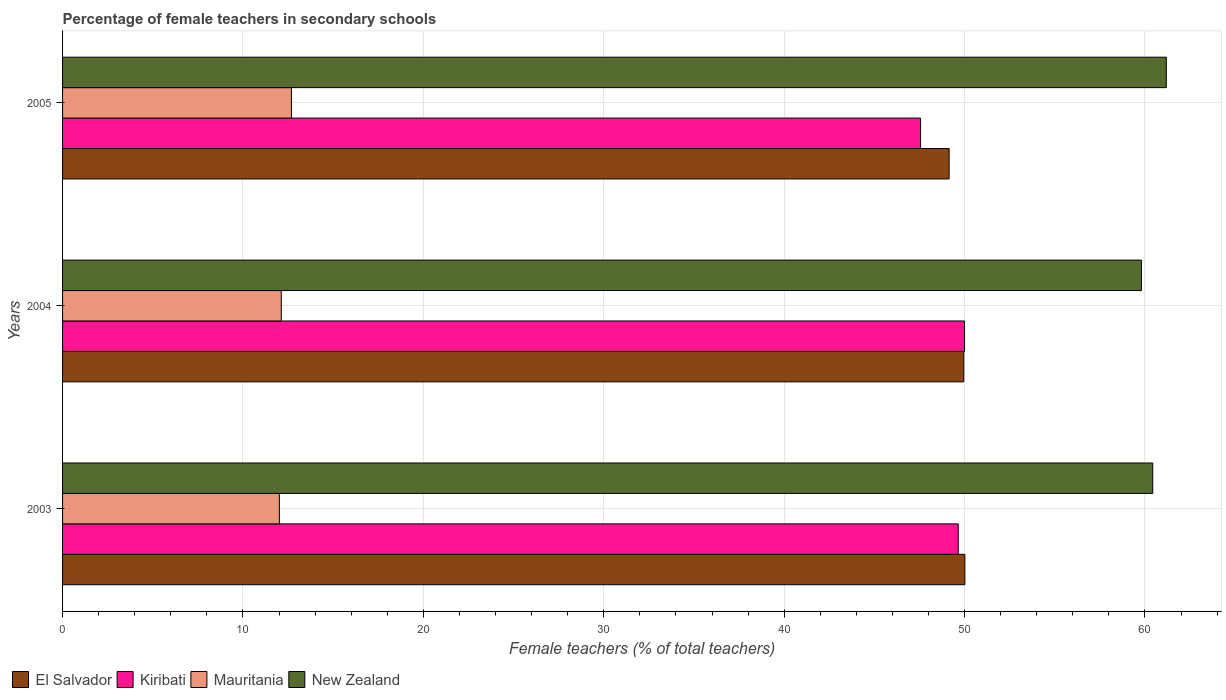Are the number of bars per tick equal to the number of legend labels?
Make the answer very short. Yes. Are the number of bars on each tick of the Y-axis equal?
Offer a very short reply. Yes. What is the label of the 1st group of bars from the top?
Make the answer very short. 2005. In how many cases, is the number of bars for a given year not equal to the number of legend labels?
Your answer should be very brief. 0. What is the percentage of female teachers in El Salvador in 2004?
Provide a short and direct response. 49.96. Across all years, what is the maximum percentage of female teachers in Kiribati?
Give a very brief answer. 50. Across all years, what is the minimum percentage of female teachers in Kiribati?
Make the answer very short. 47.56. What is the total percentage of female teachers in El Salvador in the graph?
Provide a succinct answer. 149.12. What is the difference between the percentage of female teachers in New Zealand in 2003 and that in 2004?
Offer a very short reply. 0.63. What is the difference between the percentage of female teachers in El Salvador in 2004 and the percentage of female teachers in Mauritania in 2005?
Make the answer very short. 37.27. What is the average percentage of female teachers in Mauritania per year?
Give a very brief answer. 12.28. In the year 2005, what is the difference between the percentage of female teachers in Mauritania and percentage of female teachers in New Zealand?
Offer a very short reply. -48.5. In how many years, is the percentage of female teachers in New Zealand greater than 28 %?
Ensure brevity in your answer.  3. What is the ratio of the percentage of female teachers in New Zealand in 2003 to that in 2005?
Ensure brevity in your answer.  0.99. Is the percentage of female teachers in El Salvador in 2003 less than that in 2005?
Keep it short and to the point. No. Is the difference between the percentage of female teachers in Mauritania in 2004 and 2005 greater than the difference between the percentage of female teachers in New Zealand in 2004 and 2005?
Keep it short and to the point. Yes. What is the difference between the highest and the second highest percentage of female teachers in New Zealand?
Offer a very short reply. 0.75. What is the difference between the highest and the lowest percentage of female teachers in New Zealand?
Provide a succinct answer. 1.38. What does the 4th bar from the top in 2003 represents?
Your answer should be compact. El Salvador. What does the 4th bar from the bottom in 2004 represents?
Give a very brief answer. New Zealand. Is it the case that in every year, the sum of the percentage of female teachers in Kiribati and percentage of female teachers in Mauritania is greater than the percentage of female teachers in El Salvador?
Your answer should be compact. Yes. Are all the bars in the graph horizontal?
Keep it short and to the point. Yes. How many years are there in the graph?
Ensure brevity in your answer.  3. What is the difference between two consecutive major ticks on the X-axis?
Your response must be concise. 10. Are the values on the major ticks of X-axis written in scientific E-notation?
Provide a succinct answer. No. Does the graph contain grids?
Keep it short and to the point. Yes. Where does the legend appear in the graph?
Offer a very short reply. Bottom left. How are the legend labels stacked?
Keep it short and to the point. Horizontal. What is the title of the graph?
Ensure brevity in your answer.  Percentage of female teachers in secondary schools. Does "Moldova" appear as one of the legend labels in the graph?
Keep it short and to the point. No. What is the label or title of the X-axis?
Make the answer very short. Female teachers (% of total teachers). What is the Female teachers (% of total teachers) of El Salvador in 2003?
Your answer should be very brief. 50.02. What is the Female teachers (% of total teachers) of Kiribati in 2003?
Provide a short and direct response. 49.65. What is the Female teachers (% of total teachers) in Mauritania in 2003?
Offer a terse response. 12.02. What is the Female teachers (% of total teachers) of New Zealand in 2003?
Offer a very short reply. 60.43. What is the Female teachers (% of total teachers) in El Salvador in 2004?
Your response must be concise. 49.96. What is the Female teachers (% of total teachers) of Kiribati in 2004?
Provide a short and direct response. 50. What is the Female teachers (% of total teachers) in Mauritania in 2004?
Offer a terse response. 12.12. What is the Female teachers (% of total teachers) of New Zealand in 2004?
Your answer should be compact. 59.8. What is the Female teachers (% of total teachers) of El Salvador in 2005?
Offer a terse response. 49.14. What is the Female teachers (% of total teachers) in Kiribati in 2005?
Ensure brevity in your answer.  47.56. What is the Female teachers (% of total teachers) in Mauritania in 2005?
Give a very brief answer. 12.69. What is the Female teachers (% of total teachers) in New Zealand in 2005?
Offer a terse response. 61.18. Across all years, what is the maximum Female teachers (% of total teachers) in El Salvador?
Provide a succinct answer. 50.02. Across all years, what is the maximum Female teachers (% of total teachers) in Kiribati?
Give a very brief answer. 50. Across all years, what is the maximum Female teachers (% of total teachers) of Mauritania?
Keep it short and to the point. 12.69. Across all years, what is the maximum Female teachers (% of total teachers) in New Zealand?
Your answer should be very brief. 61.18. Across all years, what is the minimum Female teachers (% of total teachers) in El Salvador?
Offer a terse response. 49.14. Across all years, what is the minimum Female teachers (% of total teachers) of Kiribati?
Provide a succinct answer. 47.56. Across all years, what is the minimum Female teachers (% of total teachers) of Mauritania?
Ensure brevity in your answer.  12.02. Across all years, what is the minimum Female teachers (% of total teachers) of New Zealand?
Make the answer very short. 59.8. What is the total Female teachers (% of total teachers) of El Salvador in the graph?
Give a very brief answer. 149.12. What is the total Female teachers (% of total teachers) of Kiribati in the graph?
Offer a very short reply. 147.21. What is the total Female teachers (% of total teachers) of Mauritania in the graph?
Provide a short and direct response. 36.83. What is the total Female teachers (% of total teachers) of New Zealand in the graph?
Provide a succinct answer. 181.42. What is the difference between the Female teachers (% of total teachers) in El Salvador in 2003 and that in 2004?
Offer a terse response. 0.06. What is the difference between the Female teachers (% of total teachers) in Kiribati in 2003 and that in 2004?
Keep it short and to the point. -0.35. What is the difference between the Female teachers (% of total teachers) in Mauritania in 2003 and that in 2004?
Your answer should be compact. -0.11. What is the difference between the Female teachers (% of total teachers) in New Zealand in 2003 and that in 2004?
Give a very brief answer. 0.63. What is the difference between the Female teachers (% of total teachers) of El Salvador in 2003 and that in 2005?
Offer a terse response. 0.87. What is the difference between the Female teachers (% of total teachers) of Kiribati in 2003 and that in 2005?
Provide a succinct answer. 2.09. What is the difference between the Female teachers (% of total teachers) in Mauritania in 2003 and that in 2005?
Offer a terse response. -0.67. What is the difference between the Female teachers (% of total teachers) in New Zealand in 2003 and that in 2005?
Make the answer very short. -0.75. What is the difference between the Female teachers (% of total teachers) of El Salvador in 2004 and that in 2005?
Give a very brief answer. 0.81. What is the difference between the Female teachers (% of total teachers) in Kiribati in 2004 and that in 2005?
Provide a succinct answer. 2.44. What is the difference between the Female teachers (% of total teachers) of Mauritania in 2004 and that in 2005?
Provide a short and direct response. -0.56. What is the difference between the Female teachers (% of total teachers) in New Zealand in 2004 and that in 2005?
Your answer should be very brief. -1.38. What is the difference between the Female teachers (% of total teachers) in El Salvador in 2003 and the Female teachers (% of total teachers) in Kiribati in 2004?
Make the answer very short. 0.02. What is the difference between the Female teachers (% of total teachers) in El Salvador in 2003 and the Female teachers (% of total teachers) in Mauritania in 2004?
Give a very brief answer. 37.89. What is the difference between the Female teachers (% of total teachers) of El Salvador in 2003 and the Female teachers (% of total teachers) of New Zealand in 2004?
Keep it short and to the point. -9.79. What is the difference between the Female teachers (% of total teachers) of Kiribati in 2003 and the Female teachers (% of total teachers) of Mauritania in 2004?
Ensure brevity in your answer.  37.53. What is the difference between the Female teachers (% of total teachers) of Kiribati in 2003 and the Female teachers (% of total teachers) of New Zealand in 2004?
Provide a succinct answer. -10.15. What is the difference between the Female teachers (% of total teachers) of Mauritania in 2003 and the Female teachers (% of total teachers) of New Zealand in 2004?
Provide a succinct answer. -47.79. What is the difference between the Female teachers (% of total teachers) of El Salvador in 2003 and the Female teachers (% of total teachers) of Kiribati in 2005?
Keep it short and to the point. 2.46. What is the difference between the Female teachers (% of total teachers) in El Salvador in 2003 and the Female teachers (% of total teachers) in Mauritania in 2005?
Keep it short and to the point. 37.33. What is the difference between the Female teachers (% of total teachers) in El Salvador in 2003 and the Female teachers (% of total teachers) in New Zealand in 2005?
Make the answer very short. -11.17. What is the difference between the Female teachers (% of total teachers) in Kiribati in 2003 and the Female teachers (% of total teachers) in Mauritania in 2005?
Your answer should be compact. 36.96. What is the difference between the Female teachers (% of total teachers) in Kiribati in 2003 and the Female teachers (% of total teachers) in New Zealand in 2005?
Offer a very short reply. -11.53. What is the difference between the Female teachers (% of total teachers) in Mauritania in 2003 and the Female teachers (% of total teachers) in New Zealand in 2005?
Give a very brief answer. -49.17. What is the difference between the Female teachers (% of total teachers) of El Salvador in 2004 and the Female teachers (% of total teachers) of Kiribati in 2005?
Your answer should be very brief. 2.39. What is the difference between the Female teachers (% of total teachers) of El Salvador in 2004 and the Female teachers (% of total teachers) of Mauritania in 2005?
Provide a succinct answer. 37.27. What is the difference between the Female teachers (% of total teachers) of El Salvador in 2004 and the Female teachers (% of total teachers) of New Zealand in 2005?
Your response must be concise. -11.23. What is the difference between the Female teachers (% of total teachers) of Kiribati in 2004 and the Female teachers (% of total teachers) of Mauritania in 2005?
Offer a very short reply. 37.31. What is the difference between the Female teachers (% of total teachers) of Kiribati in 2004 and the Female teachers (% of total teachers) of New Zealand in 2005?
Your answer should be compact. -11.18. What is the difference between the Female teachers (% of total teachers) in Mauritania in 2004 and the Female teachers (% of total teachers) in New Zealand in 2005?
Ensure brevity in your answer.  -49.06. What is the average Female teachers (% of total teachers) in El Salvador per year?
Make the answer very short. 49.71. What is the average Female teachers (% of total teachers) of Kiribati per year?
Offer a very short reply. 49.07. What is the average Female teachers (% of total teachers) of Mauritania per year?
Ensure brevity in your answer.  12.28. What is the average Female teachers (% of total teachers) of New Zealand per year?
Offer a very short reply. 60.47. In the year 2003, what is the difference between the Female teachers (% of total teachers) in El Salvador and Female teachers (% of total teachers) in Kiribati?
Provide a succinct answer. 0.37. In the year 2003, what is the difference between the Female teachers (% of total teachers) of El Salvador and Female teachers (% of total teachers) of Mauritania?
Ensure brevity in your answer.  38. In the year 2003, what is the difference between the Female teachers (% of total teachers) in El Salvador and Female teachers (% of total teachers) in New Zealand?
Ensure brevity in your answer.  -10.42. In the year 2003, what is the difference between the Female teachers (% of total teachers) in Kiribati and Female teachers (% of total teachers) in Mauritania?
Offer a terse response. 37.63. In the year 2003, what is the difference between the Female teachers (% of total teachers) of Kiribati and Female teachers (% of total teachers) of New Zealand?
Ensure brevity in your answer.  -10.78. In the year 2003, what is the difference between the Female teachers (% of total teachers) in Mauritania and Female teachers (% of total teachers) in New Zealand?
Make the answer very short. -48.42. In the year 2004, what is the difference between the Female teachers (% of total teachers) in El Salvador and Female teachers (% of total teachers) in Kiribati?
Offer a very short reply. -0.04. In the year 2004, what is the difference between the Female teachers (% of total teachers) in El Salvador and Female teachers (% of total teachers) in Mauritania?
Provide a short and direct response. 37.83. In the year 2004, what is the difference between the Female teachers (% of total teachers) in El Salvador and Female teachers (% of total teachers) in New Zealand?
Your answer should be very brief. -9.85. In the year 2004, what is the difference between the Female teachers (% of total teachers) in Kiribati and Female teachers (% of total teachers) in Mauritania?
Make the answer very short. 37.88. In the year 2004, what is the difference between the Female teachers (% of total teachers) in Kiribati and Female teachers (% of total teachers) in New Zealand?
Ensure brevity in your answer.  -9.8. In the year 2004, what is the difference between the Female teachers (% of total teachers) in Mauritania and Female teachers (% of total teachers) in New Zealand?
Provide a succinct answer. -47.68. In the year 2005, what is the difference between the Female teachers (% of total teachers) of El Salvador and Female teachers (% of total teachers) of Kiribati?
Your answer should be compact. 1.58. In the year 2005, what is the difference between the Female teachers (% of total teachers) in El Salvador and Female teachers (% of total teachers) in Mauritania?
Provide a short and direct response. 36.46. In the year 2005, what is the difference between the Female teachers (% of total teachers) of El Salvador and Female teachers (% of total teachers) of New Zealand?
Your answer should be very brief. -12.04. In the year 2005, what is the difference between the Female teachers (% of total teachers) in Kiribati and Female teachers (% of total teachers) in Mauritania?
Offer a very short reply. 34.88. In the year 2005, what is the difference between the Female teachers (% of total teachers) in Kiribati and Female teachers (% of total teachers) in New Zealand?
Your answer should be very brief. -13.62. In the year 2005, what is the difference between the Female teachers (% of total teachers) of Mauritania and Female teachers (% of total teachers) of New Zealand?
Ensure brevity in your answer.  -48.5. What is the ratio of the Female teachers (% of total teachers) of Kiribati in 2003 to that in 2004?
Provide a short and direct response. 0.99. What is the ratio of the Female teachers (% of total teachers) in New Zealand in 2003 to that in 2004?
Your answer should be very brief. 1.01. What is the ratio of the Female teachers (% of total teachers) in El Salvador in 2003 to that in 2005?
Provide a short and direct response. 1.02. What is the ratio of the Female teachers (% of total teachers) of Kiribati in 2003 to that in 2005?
Your answer should be compact. 1.04. What is the ratio of the Female teachers (% of total teachers) of Mauritania in 2003 to that in 2005?
Provide a succinct answer. 0.95. What is the ratio of the Female teachers (% of total teachers) in El Salvador in 2004 to that in 2005?
Ensure brevity in your answer.  1.02. What is the ratio of the Female teachers (% of total teachers) of Kiribati in 2004 to that in 2005?
Ensure brevity in your answer.  1.05. What is the ratio of the Female teachers (% of total teachers) in Mauritania in 2004 to that in 2005?
Keep it short and to the point. 0.96. What is the ratio of the Female teachers (% of total teachers) of New Zealand in 2004 to that in 2005?
Give a very brief answer. 0.98. What is the difference between the highest and the second highest Female teachers (% of total teachers) in El Salvador?
Offer a very short reply. 0.06. What is the difference between the highest and the second highest Female teachers (% of total teachers) of Kiribati?
Offer a terse response. 0.35. What is the difference between the highest and the second highest Female teachers (% of total teachers) in Mauritania?
Provide a succinct answer. 0.56. What is the difference between the highest and the second highest Female teachers (% of total teachers) of New Zealand?
Offer a very short reply. 0.75. What is the difference between the highest and the lowest Female teachers (% of total teachers) in El Salvador?
Ensure brevity in your answer.  0.87. What is the difference between the highest and the lowest Female teachers (% of total teachers) in Kiribati?
Offer a terse response. 2.44. What is the difference between the highest and the lowest Female teachers (% of total teachers) of Mauritania?
Provide a short and direct response. 0.67. What is the difference between the highest and the lowest Female teachers (% of total teachers) of New Zealand?
Give a very brief answer. 1.38. 